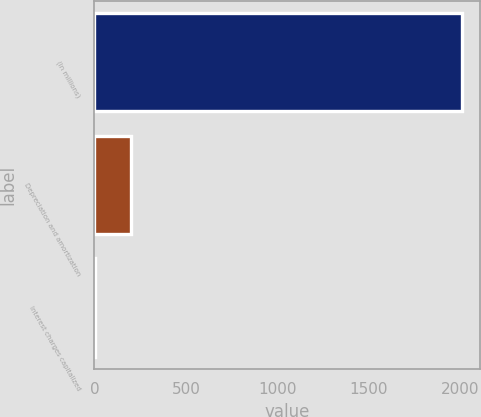Convert chart. <chart><loc_0><loc_0><loc_500><loc_500><bar_chart><fcel>(In millions)<fcel>Depreciation and amortization<fcel>Interest charges capitalized<nl><fcel>2010<fcel>201.9<fcel>1<nl></chart> 